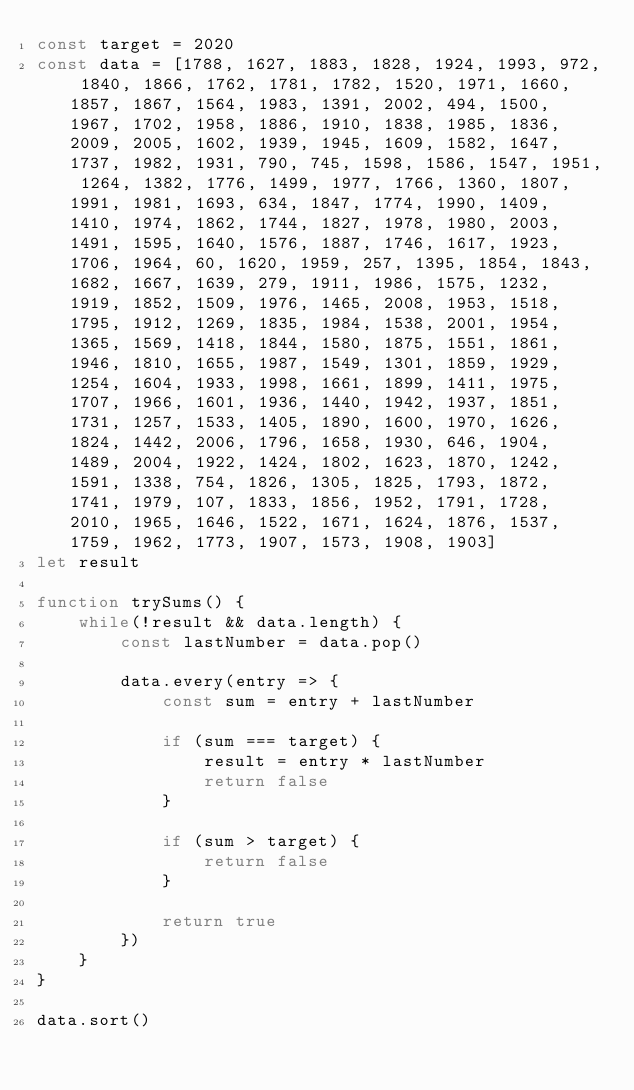Convert code to text. <code><loc_0><loc_0><loc_500><loc_500><_JavaScript_>const target = 2020
const data = [1788, 1627, 1883, 1828, 1924, 1993, 972, 1840, 1866, 1762, 1781, 1782, 1520, 1971, 1660, 1857, 1867, 1564, 1983, 1391, 2002, 494, 1500, 1967, 1702, 1958, 1886, 1910, 1838, 1985, 1836, 2009, 2005, 1602, 1939, 1945, 1609, 1582, 1647, 1737, 1982, 1931, 790, 745, 1598, 1586, 1547, 1951, 1264, 1382, 1776, 1499, 1977, 1766, 1360, 1807, 1991, 1981, 1693, 634, 1847, 1774, 1990, 1409, 1410, 1974, 1862, 1744, 1827, 1978, 1980, 2003, 1491, 1595, 1640, 1576, 1887, 1746, 1617, 1923, 1706, 1964, 60, 1620, 1959, 257, 1395, 1854, 1843, 1682, 1667, 1639, 279, 1911, 1986, 1575, 1232, 1919, 1852, 1509, 1976, 1465, 2008, 1953, 1518, 1795, 1912, 1269, 1835, 1984, 1538, 2001, 1954, 1365, 1569, 1418, 1844, 1580, 1875, 1551, 1861, 1946, 1810, 1655, 1987, 1549, 1301, 1859, 1929, 1254, 1604, 1933, 1998, 1661, 1899, 1411, 1975, 1707, 1966, 1601, 1936, 1440, 1942, 1937, 1851, 1731, 1257, 1533, 1405, 1890, 1600, 1970, 1626, 1824, 1442, 2006, 1796, 1658, 1930, 646, 1904, 1489, 2004, 1922, 1424, 1802, 1623, 1870, 1242, 1591, 1338, 754, 1826, 1305, 1825, 1793, 1872, 1741, 1979, 107, 1833, 1856, 1952, 1791, 1728, 2010, 1965, 1646, 1522, 1671, 1624, 1876, 1537, 1759, 1962, 1773, 1907, 1573, 1908, 1903]
let result

function trySums() {
	while(!result && data.length) {
		const lastNumber = data.pop()
		
		data.every(entry => {
			const sum = entry + lastNumber
			
			if (sum === target) {
				result = entry * lastNumber
				return false
			}
			
			if (sum > target) {
				return false
			}
			
			return true
		})
	}
}

data.sort()</code> 